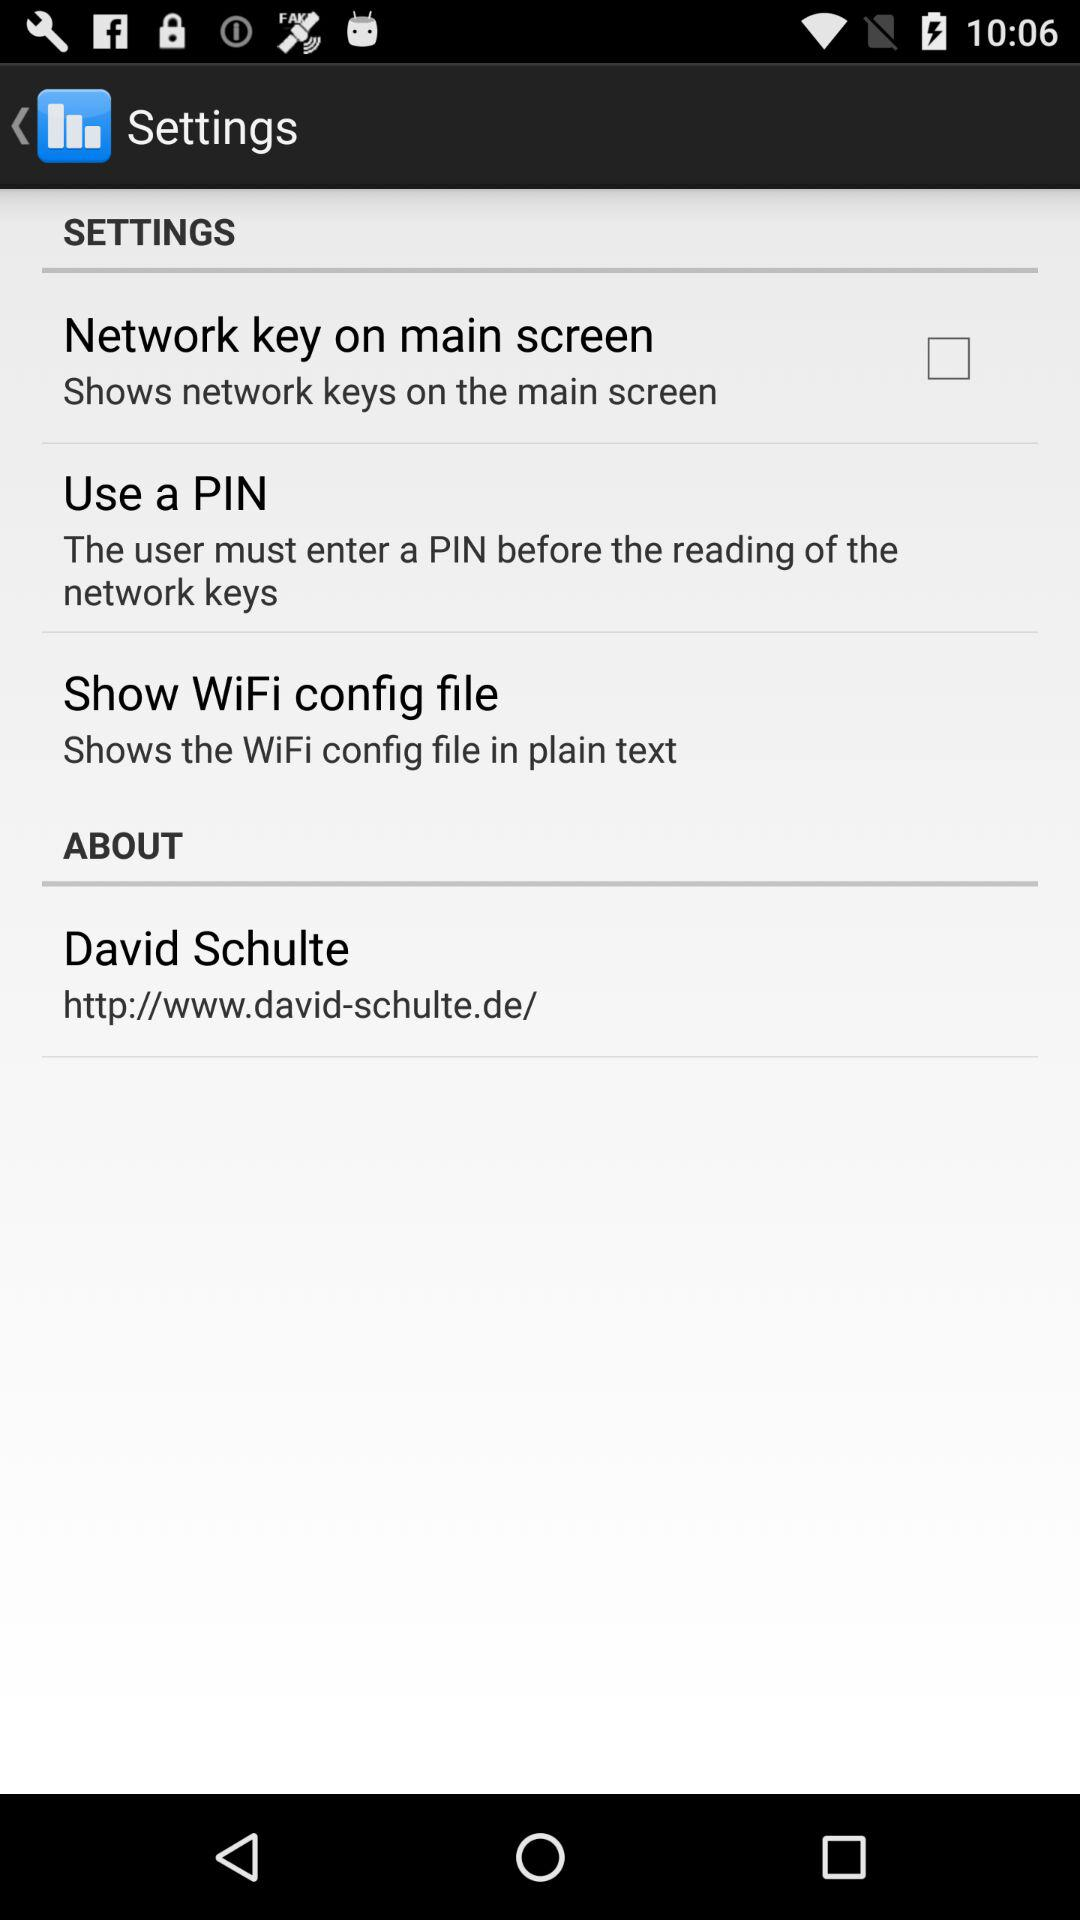What is the status of the "Network key on main screen"? The status is off. 